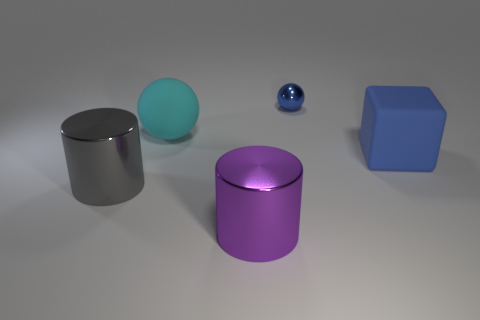Add 5 small rubber spheres. How many objects exist? 10 Subtract all cubes. How many objects are left? 4 Subtract all tiny purple cubes. Subtract all gray things. How many objects are left? 4 Add 1 big blue objects. How many big blue objects are left? 2 Add 1 large gray rubber cylinders. How many large gray rubber cylinders exist? 1 Subtract 0 green balls. How many objects are left? 5 